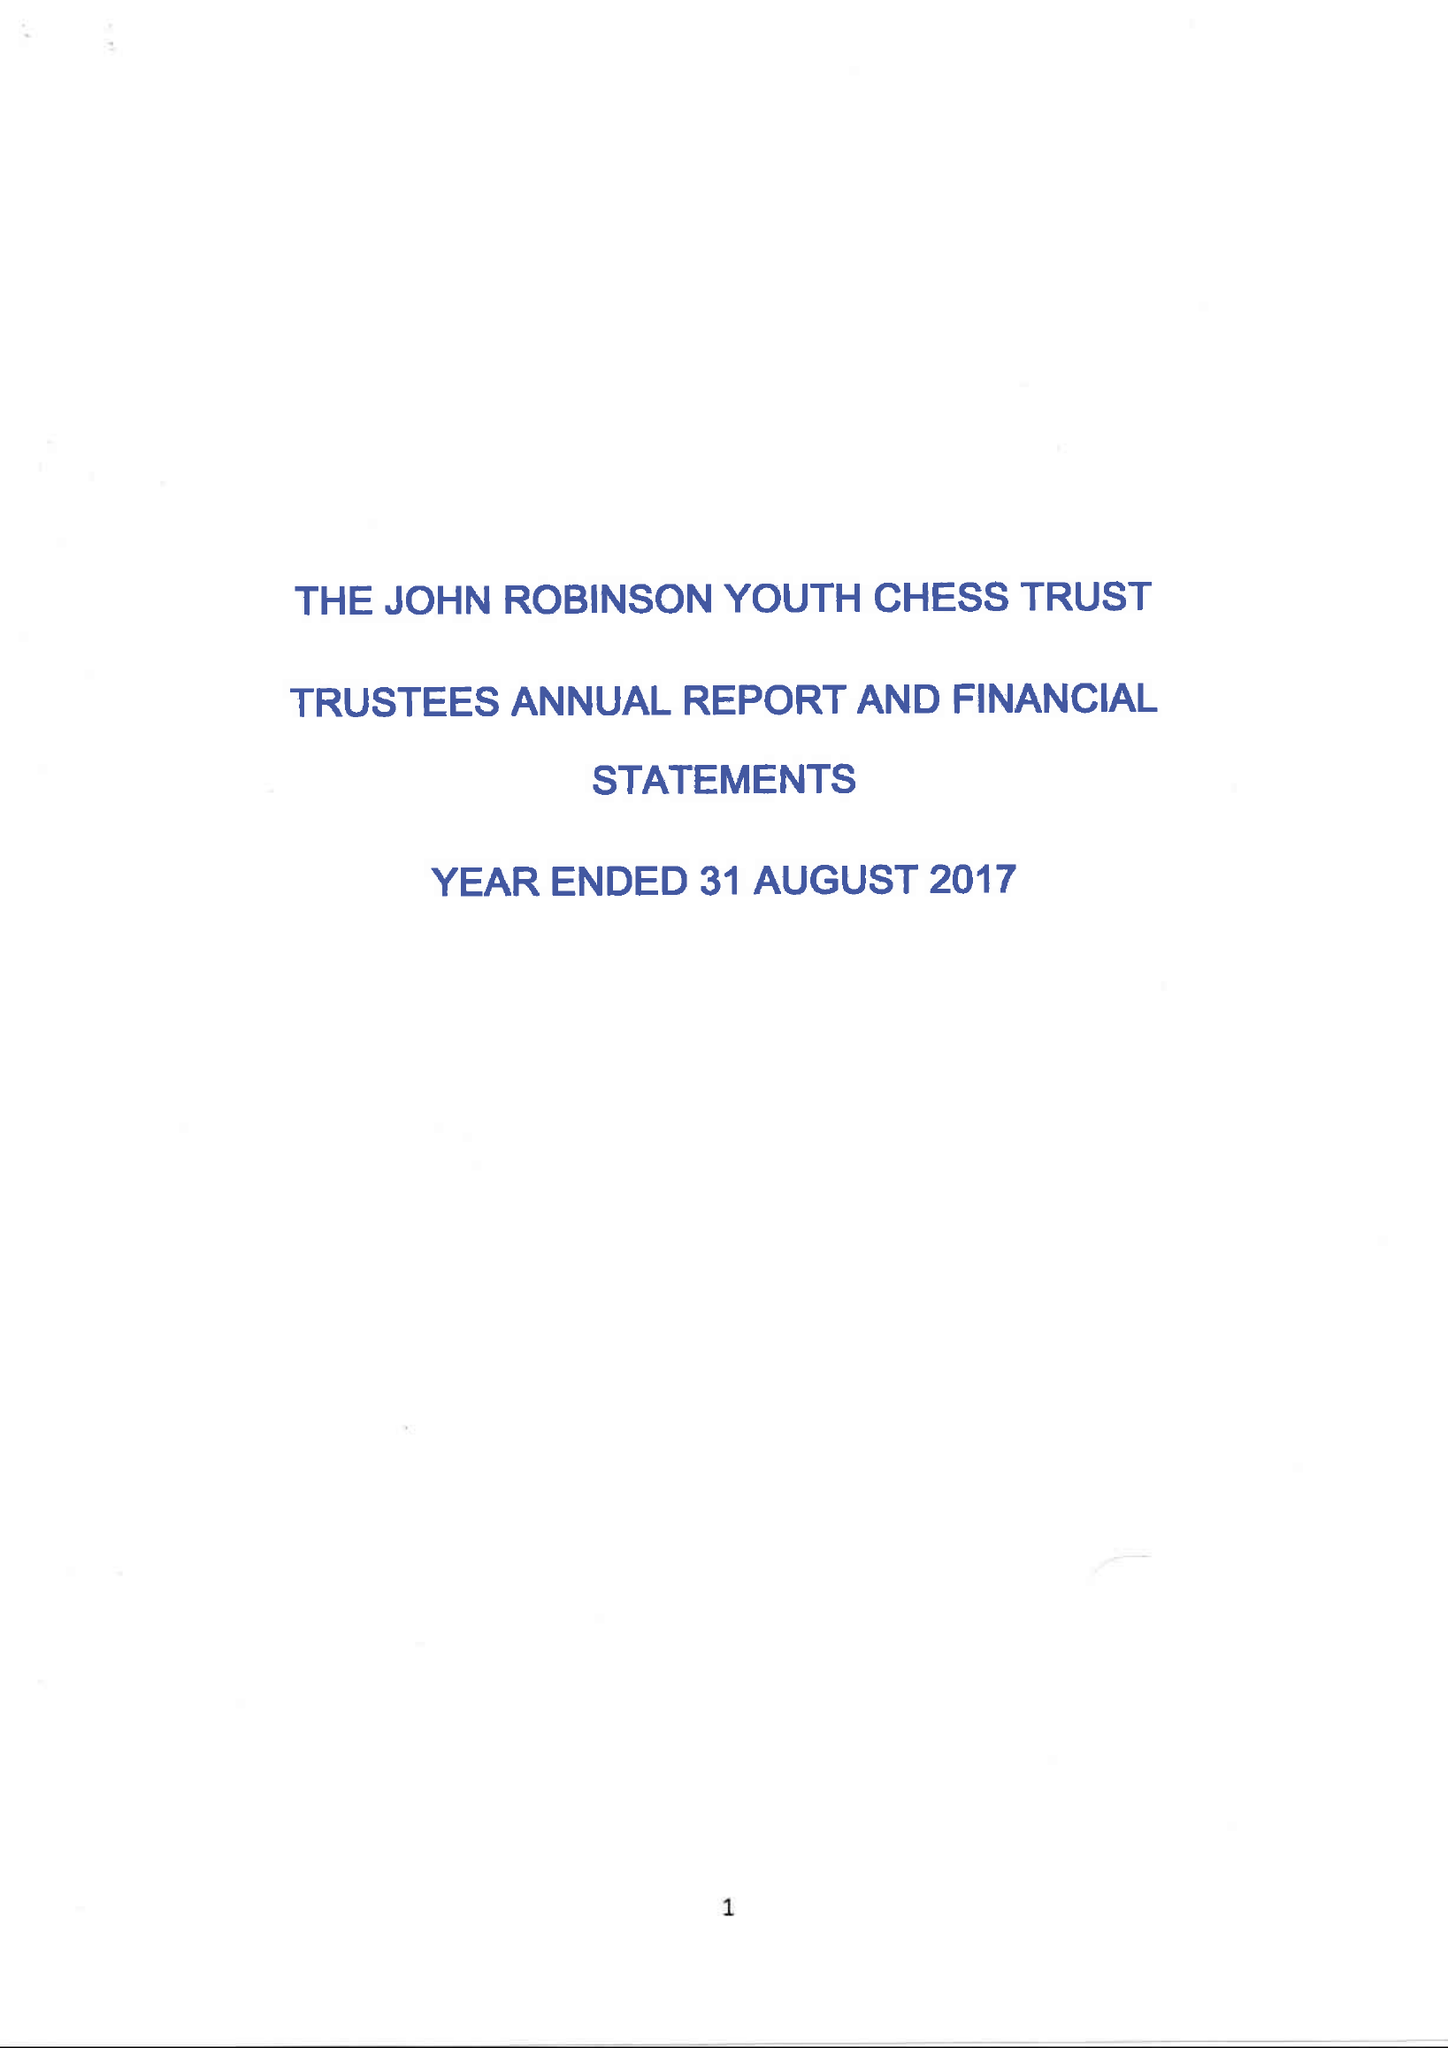What is the value for the report_date?
Answer the question using a single word or phrase. 2017-08-31 